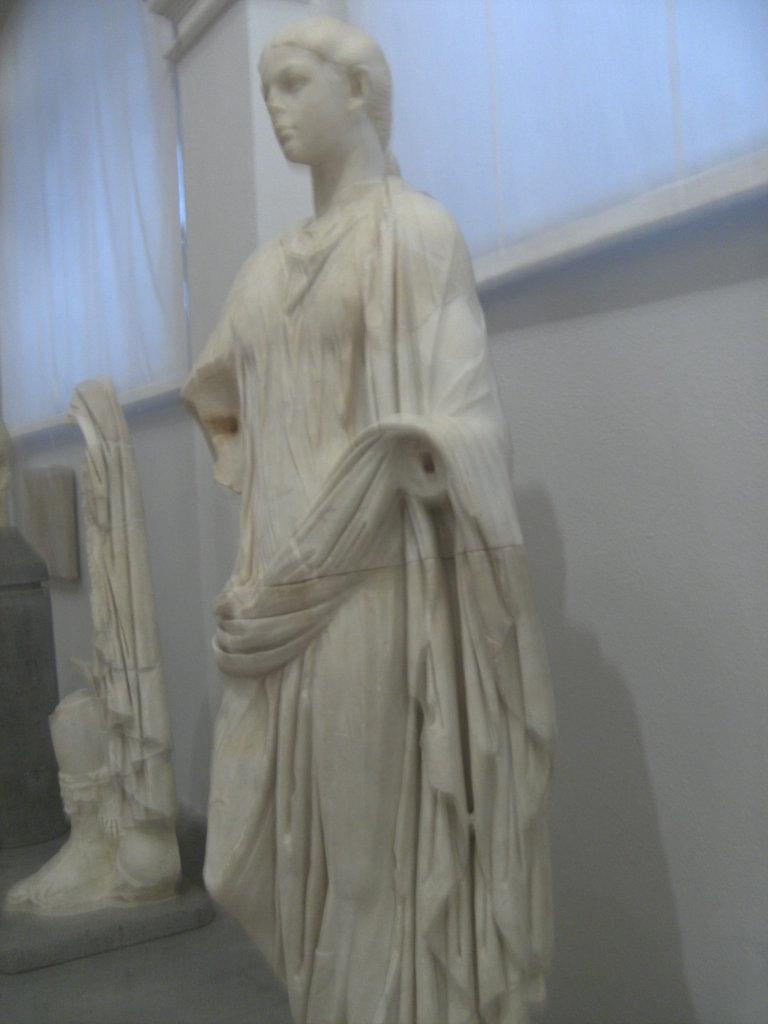What is the main subject in the image? There is a statue in the image. Where is the statue located? The statue is on a platform. What can be seen in the background of the image? There is a wall in the background of the image. How many cables are connected to the statue in the image? There are no cables connected to the statue in the image. What type of truck is parked near the statue in the image? There is no truck present in the image. 